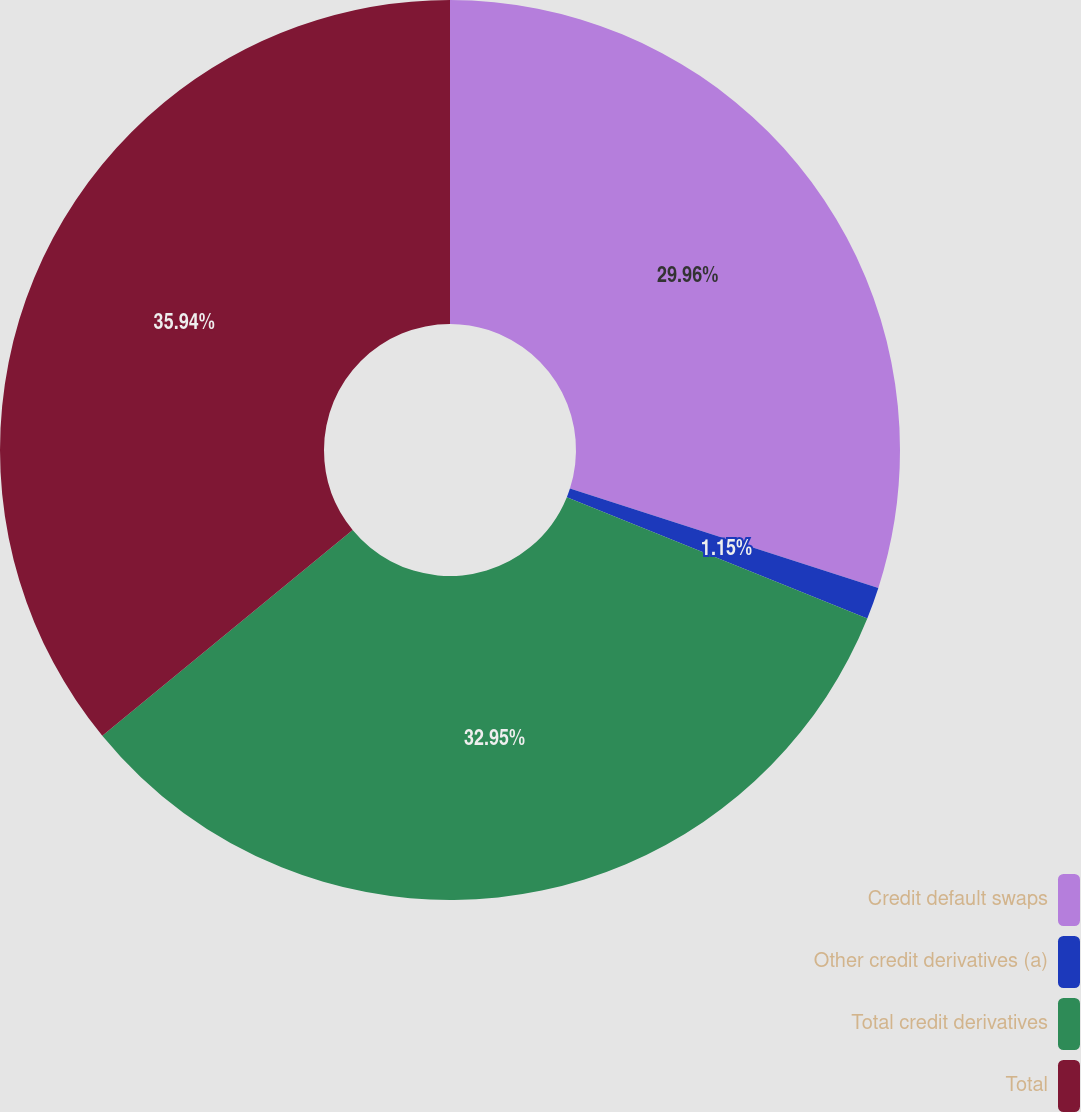Convert chart to OTSL. <chart><loc_0><loc_0><loc_500><loc_500><pie_chart><fcel>Credit default swaps<fcel>Other credit derivatives (a)<fcel>Total credit derivatives<fcel>Total<nl><fcel>29.96%<fcel>1.15%<fcel>32.95%<fcel>35.95%<nl></chart> 